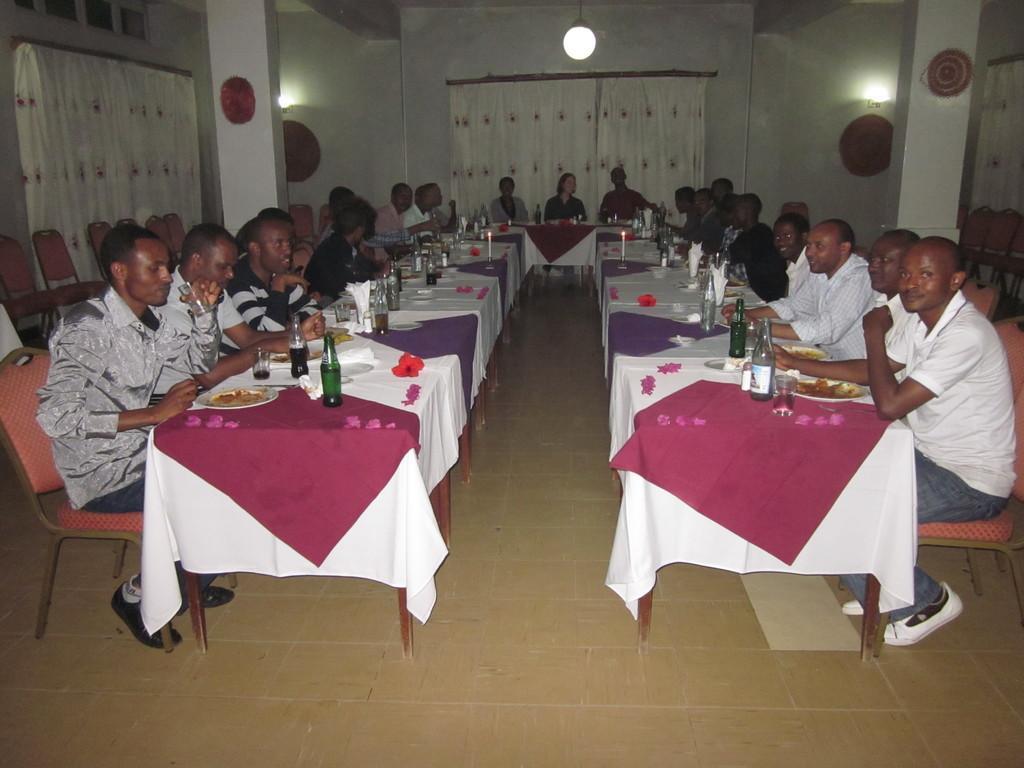How would you summarize this image in a sentence or two? In the image we can see there are people who are sitting on the dining table and in front of them there are food in the plates and wine bottles. Behind them there is a white curtain and above it there is a light which is hanging on the top. 